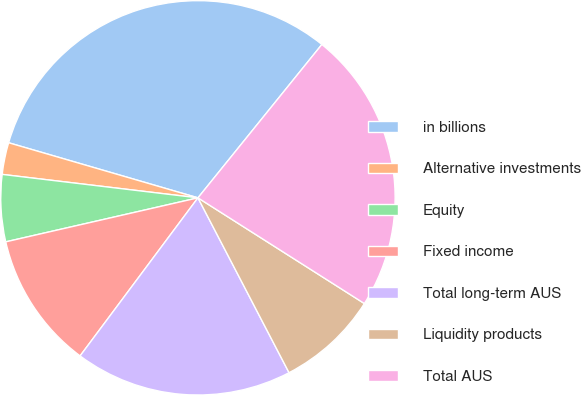Convert chart. <chart><loc_0><loc_0><loc_500><loc_500><pie_chart><fcel>in billions<fcel>Alternative investments<fcel>Equity<fcel>Fixed income<fcel>Total long-term AUS<fcel>Liquidity products<fcel>Total AUS<nl><fcel>31.31%<fcel>2.61%<fcel>5.48%<fcel>11.22%<fcel>17.84%<fcel>8.35%<fcel>23.19%<nl></chart> 